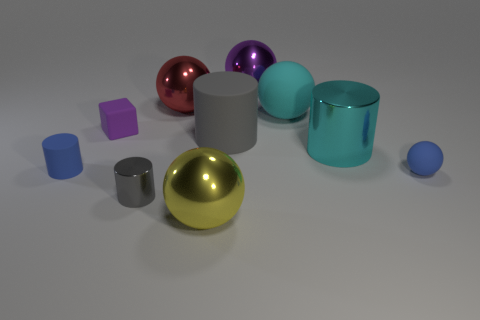Subtract all yellow spheres. How many gray cylinders are left? 2 Subtract all blue spheres. How many spheres are left? 4 Subtract all cyan cylinders. How many cylinders are left? 3 Subtract 1 cylinders. How many cylinders are left? 3 Subtract all green cylinders. Subtract all brown blocks. How many cylinders are left? 4 Add 7 green matte objects. How many green matte objects exist? 7 Subtract 0 gray spheres. How many objects are left? 10 Subtract all cylinders. How many objects are left? 6 Subtract all blue cylinders. Subtract all small matte spheres. How many objects are left? 8 Add 9 gray metal cylinders. How many gray metal cylinders are left? 10 